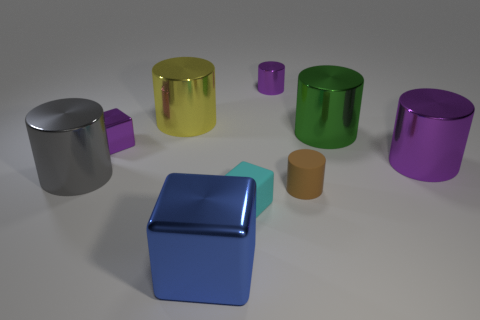Subtract all gray cubes. How many purple cylinders are left? 2 Subtract all brown cylinders. How many cylinders are left? 5 Subtract all purple metallic cylinders. How many cylinders are left? 4 Subtract 1 cylinders. How many cylinders are left? 5 Subtract all blue cylinders. Subtract all cyan blocks. How many cylinders are left? 6 Add 1 large blue blocks. How many objects exist? 10 Subtract all cubes. How many objects are left? 6 Subtract 0 green balls. How many objects are left? 9 Subtract all matte cylinders. Subtract all large purple cylinders. How many objects are left? 7 Add 3 small cylinders. How many small cylinders are left? 5 